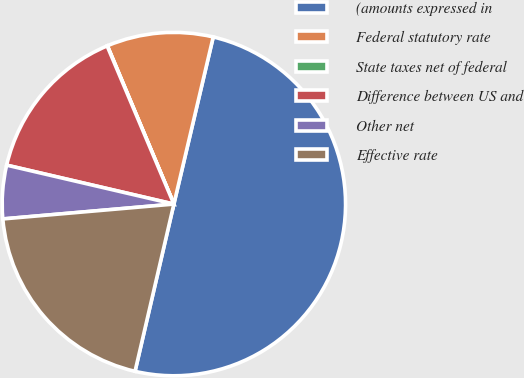Convert chart. <chart><loc_0><loc_0><loc_500><loc_500><pie_chart><fcel>(amounts expressed in<fcel>Federal statutory rate<fcel>State taxes net of federal<fcel>Difference between US and<fcel>Other net<fcel>Effective rate<nl><fcel>49.95%<fcel>10.01%<fcel>0.03%<fcel>15.0%<fcel>5.02%<fcel>19.99%<nl></chart> 